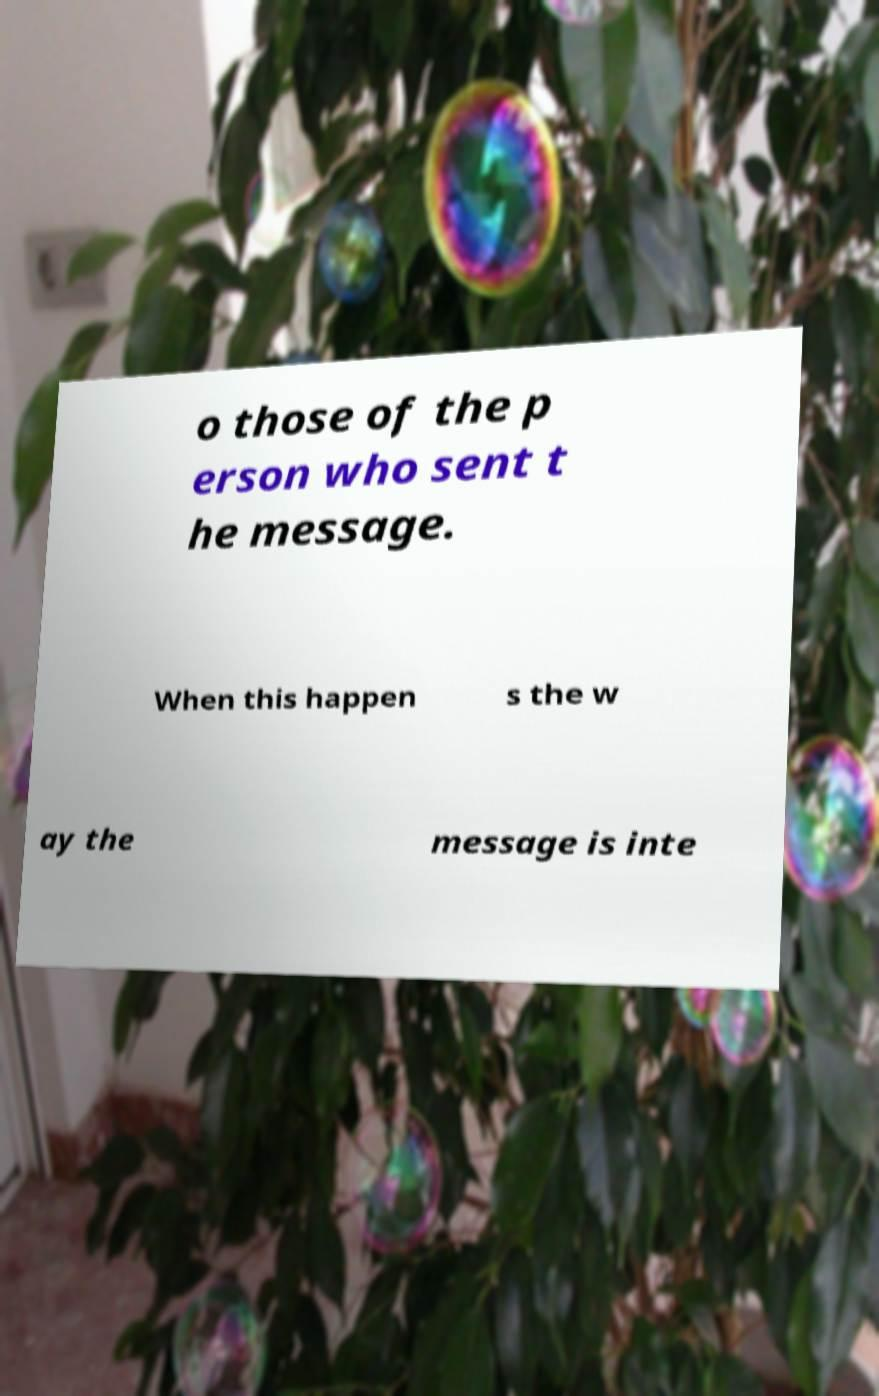Can you read and provide the text displayed in the image?This photo seems to have some interesting text. Can you extract and type it out for me? o those of the p erson who sent t he message. When this happen s the w ay the message is inte 